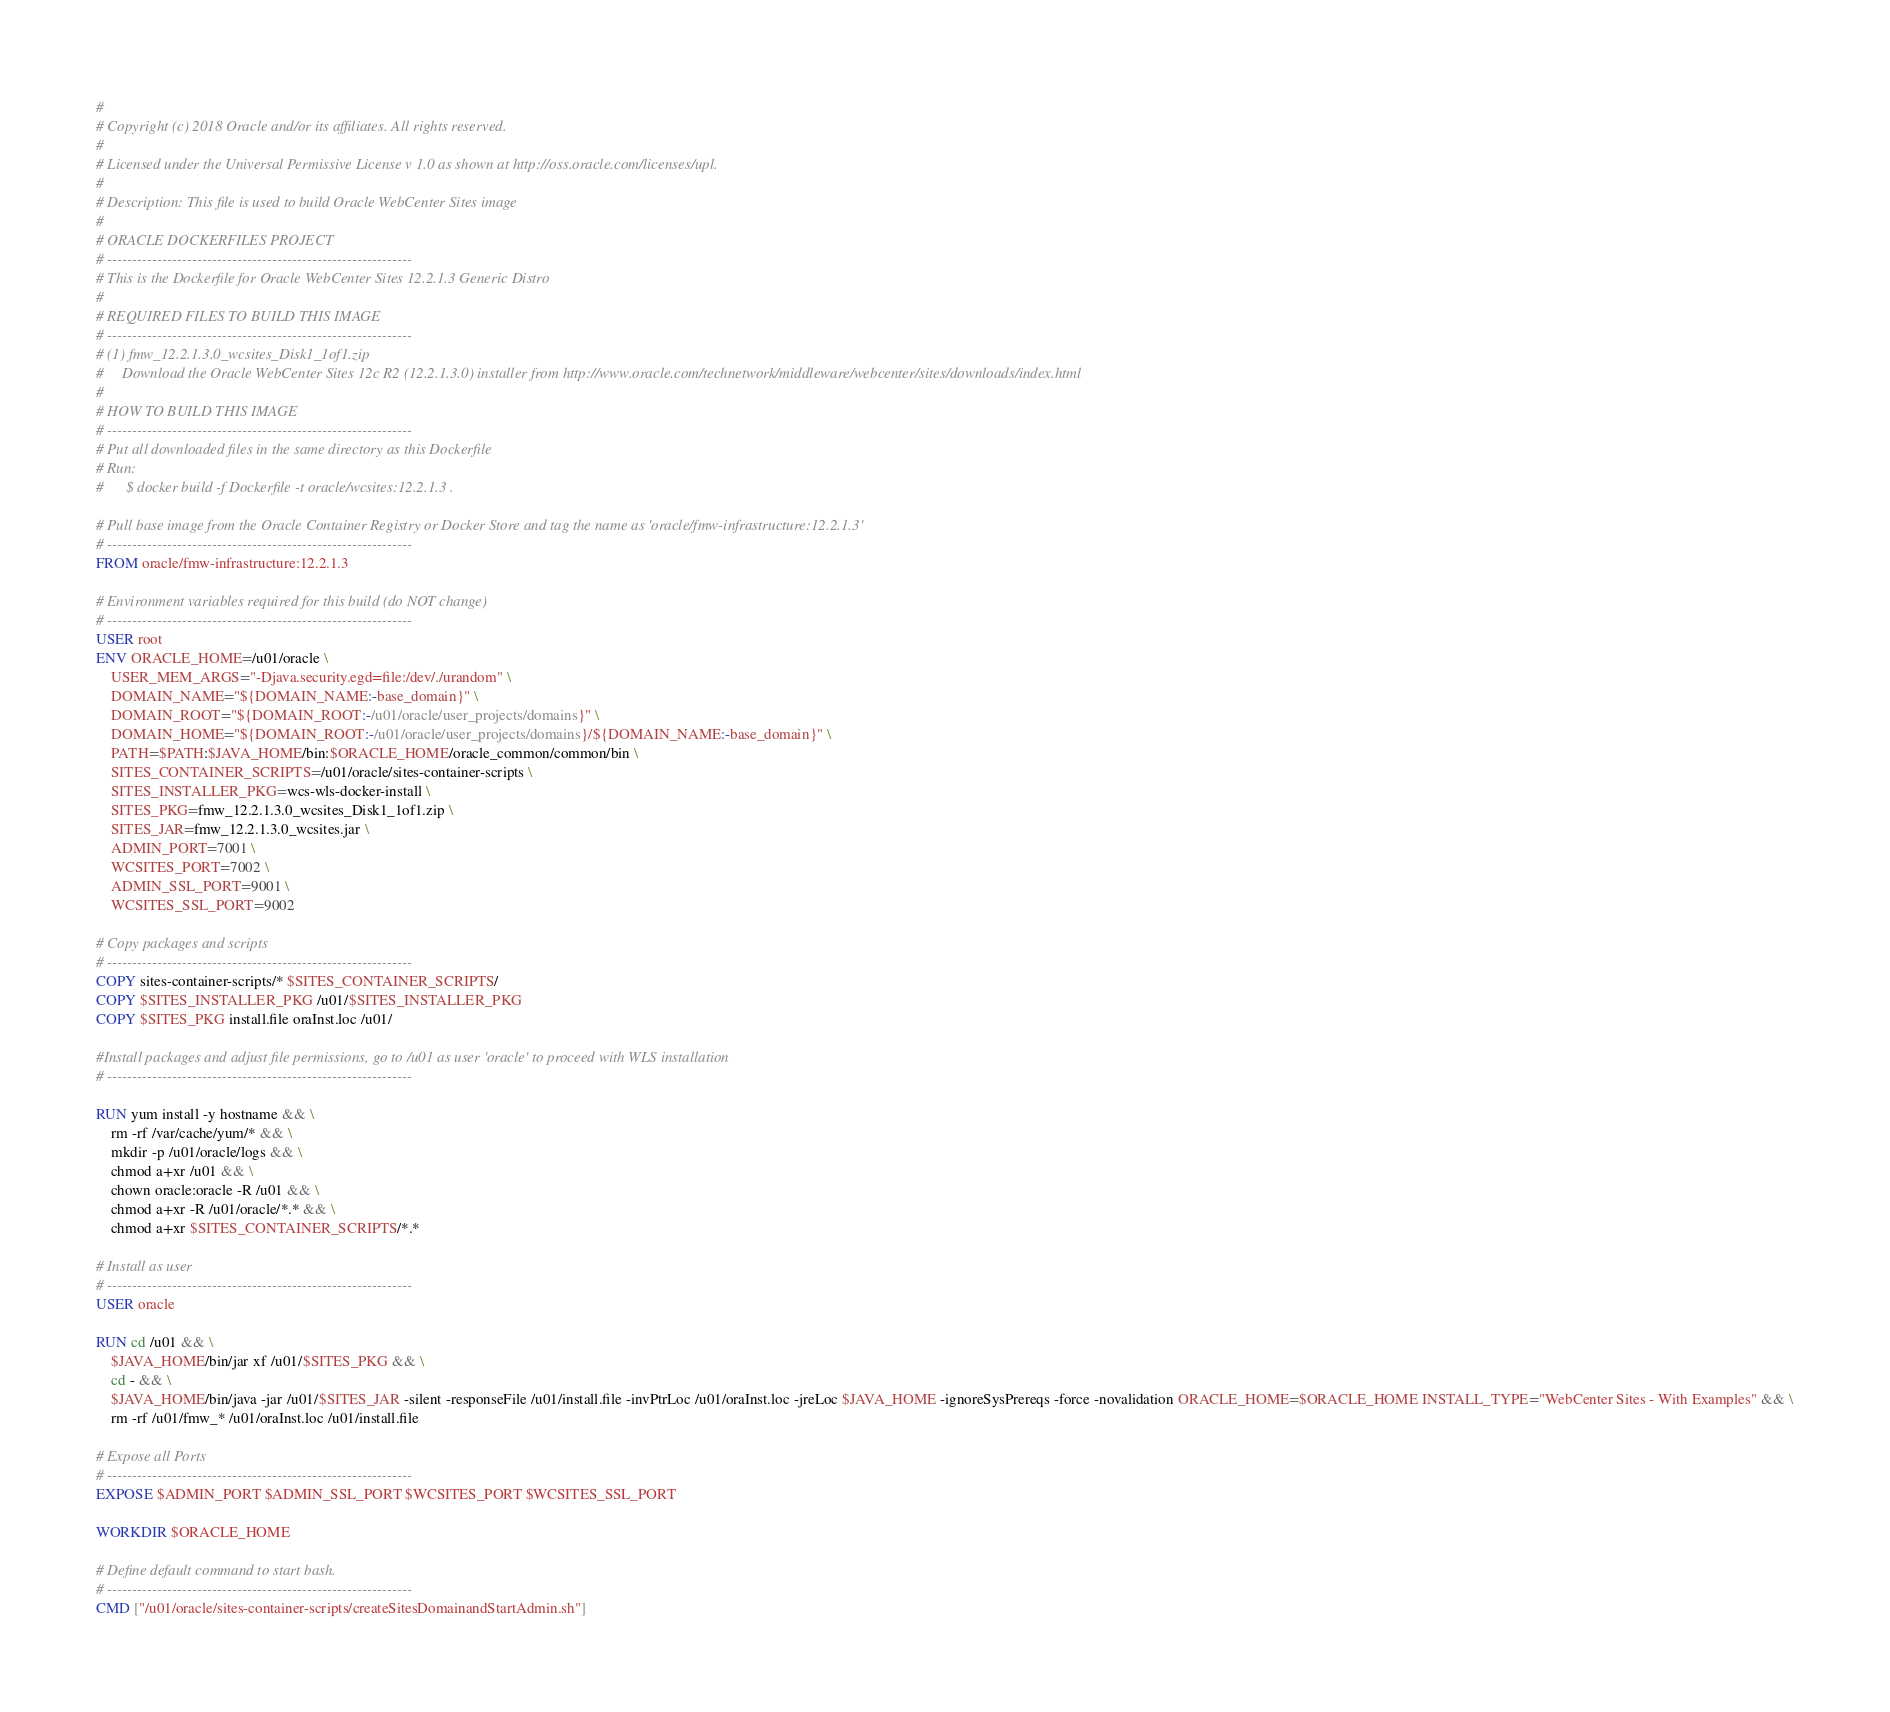<code> <loc_0><loc_0><loc_500><loc_500><_Dockerfile_>#
# Copyright (c) 2018 Oracle and/or its affiliates. All rights reserved.
#
# Licensed under the Universal Permissive License v 1.0 as shown at http://oss.oracle.com/licenses/upl.
#
# Description: This file is used to build Oracle WebCenter Sites image
#
# ORACLE DOCKERFILES PROJECT
# -------------------------------------------------------------
# This is the Dockerfile for Oracle WebCenter Sites 12.2.1.3 Generic Distro
# 
# REQUIRED FILES TO BUILD THIS IMAGE
# -------------------------------------------------------------
# (1) fmw_12.2.1.3.0_wcsites_Disk1_1of1.zip
#     Download the Oracle WebCenter Sites 12c R2 (12.2.1.3.0) installer from http://www.oracle.com/technetwork/middleware/webcenter/sites/downloads/index.html
#
# HOW TO BUILD THIS IMAGE
# -------------------------------------------------------------
# Put all downloaded files in the same directory as this Dockerfile
# Run: 
#      $ docker build -f Dockerfile -t oracle/wcsites:12.2.1.3 . 

# Pull base image from the Oracle Container Registry or Docker Store and tag the name as 'oracle/fmw-infrastructure:12.2.1.3'
# -------------------------------------------------------------
FROM oracle/fmw-infrastructure:12.2.1.3

# Environment variables required for this build (do NOT change)
# -------------------------------------------------------------
USER root
ENV ORACLE_HOME=/u01/oracle \
	USER_MEM_ARGS="-Djava.security.egd=file:/dev/./urandom" \
	DOMAIN_NAME="${DOMAIN_NAME:-base_domain}" \
	DOMAIN_ROOT="${DOMAIN_ROOT:-/u01/oracle/user_projects/domains}" \
	DOMAIN_HOME="${DOMAIN_ROOT:-/u01/oracle/user_projects/domains}/${DOMAIN_NAME:-base_domain}" \
	PATH=$PATH:$JAVA_HOME/bin:$ORACLE_HOME/oracle_common/common/bin \
	SITES_CONTAINER_SCRIPTS=/u01/oracle/sites-container-scripts \
	SITES_INSTALLER_PKG=wcs-wls-docker-install \
	SITES_PKG=fmw_12.2.1.3.0_wcsites_Disk1_1of1.zip \
	SITES_JAR=fmw_12.2.1.3.0_wcsites.jar \
	ADMIN_PORT=7001 \
	WCSITES_PORT=7002 \
	ADMIN_SSL_PORT=9001 \
	WCSITES_SSL_PORT=9002
	
# Copy packages and scripts 
# -------------------------------------------------------------
COPY sites-container-scripts/* $SITES_CONTAINER_SCRIPTS/
COPY $SITES_INSTALLER_PKG /u01/$SITES_INSTALLER_PKG
COPY $SITES_PKG install.file oraInst.loc /u01/

#Install packages and adjust file permissions, go to /u01 as user 'oracle' to proceed with WLS installation
# -------------------------------------------------------------

RUN yum install -y hostname && \
	rm -rf /var/cache/yum/* && \
	mkdir -p /u01/oracle/logs && \
	chmod a+xr /u01 && \
	chown oracle:oracle -R /u01 && \
	chmod a+xr -R /u01/oracle/*.* && \
	chmod a+xr $SITES_CONTAINER_SCRIPTS/*.*
	
# Install as user
# -------------------------------------------------------------
USER oracle

RUN cd /u01 && \
	$JAVA_HOME/bin/jar xf /u01/$SITES_PKG && \
	cd - && \
	$JAVA_HOME/bin/java -jar /u01/$SITES_JAR -silent -responseFile /u01/install.file -invPtrLoc /u01/oraInst.loc -jreLoc $JAVA_HOME -ignoreSysPrereqs -force -novalidation ORACLE_HOME=$ORACLE_HOME INSTALL_TYPE="WebCenter Sites - With Examples" && \
	rm -rf /u01/fmw_* /u01/oraInst.loc /u01/install.file

# Expose all Ports
# -------------------------------------------------------------
EXPOSE $ADMIN_PORT $ADMIN_SSL_PORT $WCSITES_PORT $WCSITES_SSL_PORT

WORKDIR $ORACLE_HOME

# Define default command to start bash.
# -------------------------------------------------------------
CMD ["/u01/oracle/sites-container-scripts/createSitesDomainandStartAdmin.sh"]</code> 